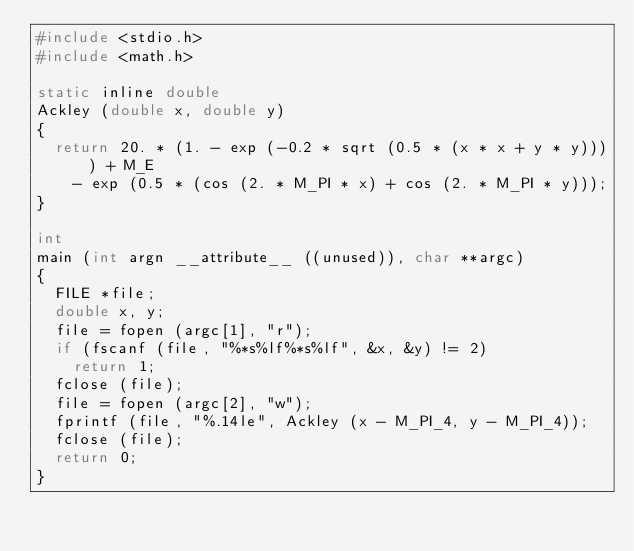Convert code to text. <code><loc_0><loc_0><loc_500><loc_500><_C_>#include <stdio.h>
#include <math.h>

static inline double
Ackley (double x, double y)
{
  return 20. * (1. - exp (-0.2 * sqrt (0.5 * (x * x + y * y)))) + M_E
    - exp (0.5 * (cos (2. * M_PI * x) + cos (2. * M_PI * y)));
}

int
main (int argn __attribute__ ((unused)), char **argc)
{
  FILE *file;
  double x, y;
  file = fopen (argc[1], "r");
  if (fscanf (file, "%*s%lf%*s%lf", &x, &y) != 2)
    return 1;
  fclose (file);
  file = fopen (argc[2], "w");
  fprintf (file, "%.14le", Ackley (x - M_PI_4, y - M_PI_4));
  fclose (file);
  return 0;
}
</code> 